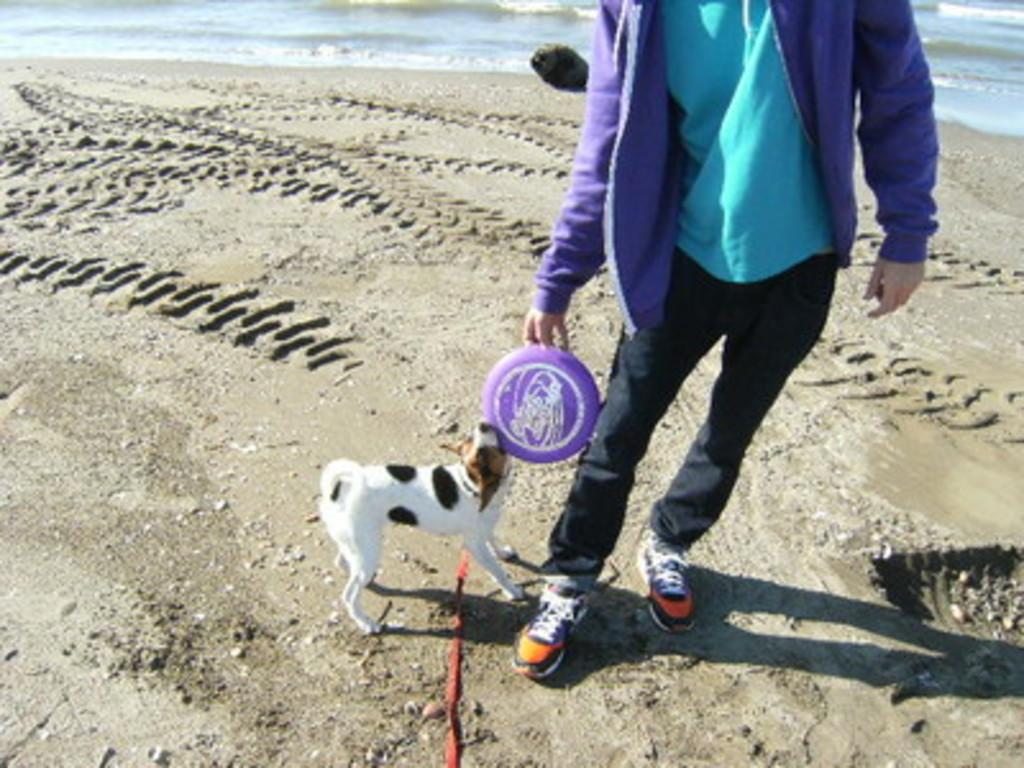Who is present in the image? There is a person in the image. What other living creature is in the image? There is a dog in the image. What are the person and the dog doing together? They are playing together. What are they holding while playing? They are both holding an object. What can be seen in the background of the image? There is sand and water in the background of the image. What type of veil is draped over the cactus in the image? There is no veil or cactus present in the image. What key is used to unlock the door in the image? There is no door or key present in the image. 